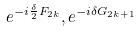Convert formula to latex. <formula><loc_0><loc_0><loc_500><loc_500>e ^ { - i \frac { \delta } { 2 } F _ { 2 k } } , e ^ { - i \delta G _ { 2 k + 1 } }</formula> 